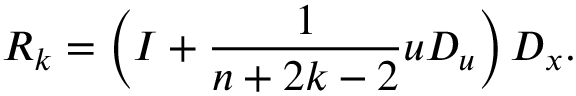<formula> <loc_0><loc_0><loc_500><loc_500>R _ { k } = \left ( I + { \frac { 1 } { n + 2 k - 2 } } u D _ { u } \right ) D _ { x } .</formula> 